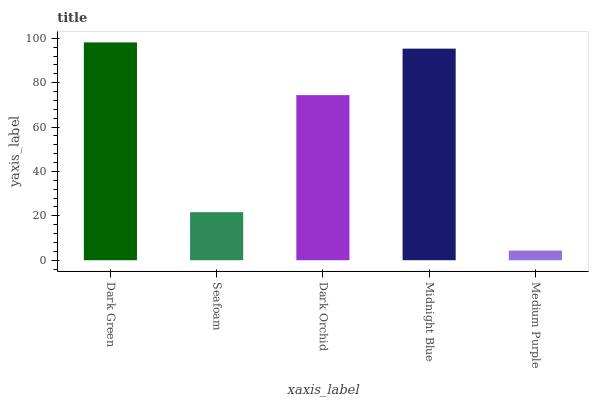Is Medium Purple the minimum?
Answer yes or no. Yes. Is Dark Green the maximum?
Answer yes or no. Yes. Is Seafoam the minimum?
Answer yes or no. No. Is Seafoam the maximum?
Answer yes or no. No. Is Dark Green greater than Seafoam?
Answer yes or no. Yes. Is Seafoam less than Dark Green?
Answer yes or no. Yes. Is Seafoam greater than Dark Green?
Answer yes or no. No. Is Dark Green less than Seafoam?
Answer yes or no. No. Is Dark Orchid the high median?
Answer yes or no. Yes. Is Dark Orchid the low median?
Answer yes or no. Yes. Is Midnight Blue the high median?
Answer yes or no. No. Is Midnight Blue the low median?
Answer yes or no. No. 